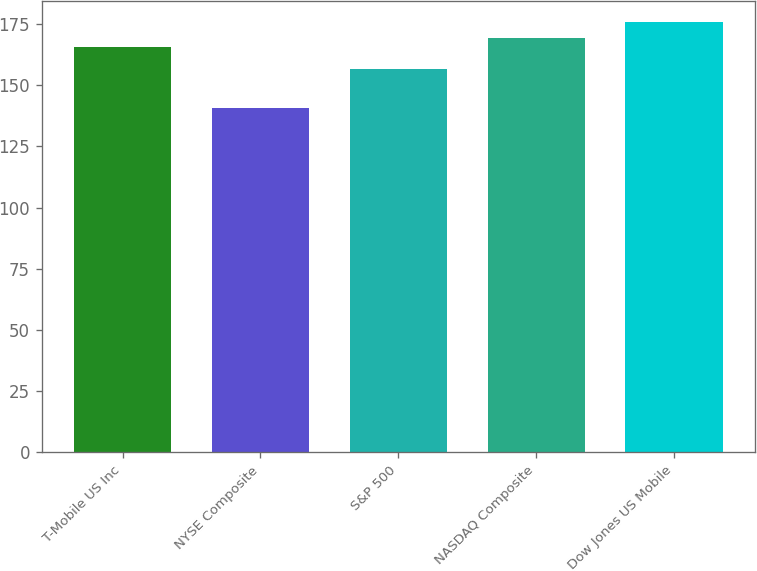<chart> <loc_0><loc_0><loc_500><loc_500><bar_chart><fcel>T-Mobile US Inc<fcel>NYSE Composite<fcel>S&P 500<fcel>NASDAQ Composite<fcel>Dow Jones US Mobile<nl><fcel>165.82<fcel>140.85<fcel>156.82<fcel>169.32<fcel>175.81<nl></chart> 